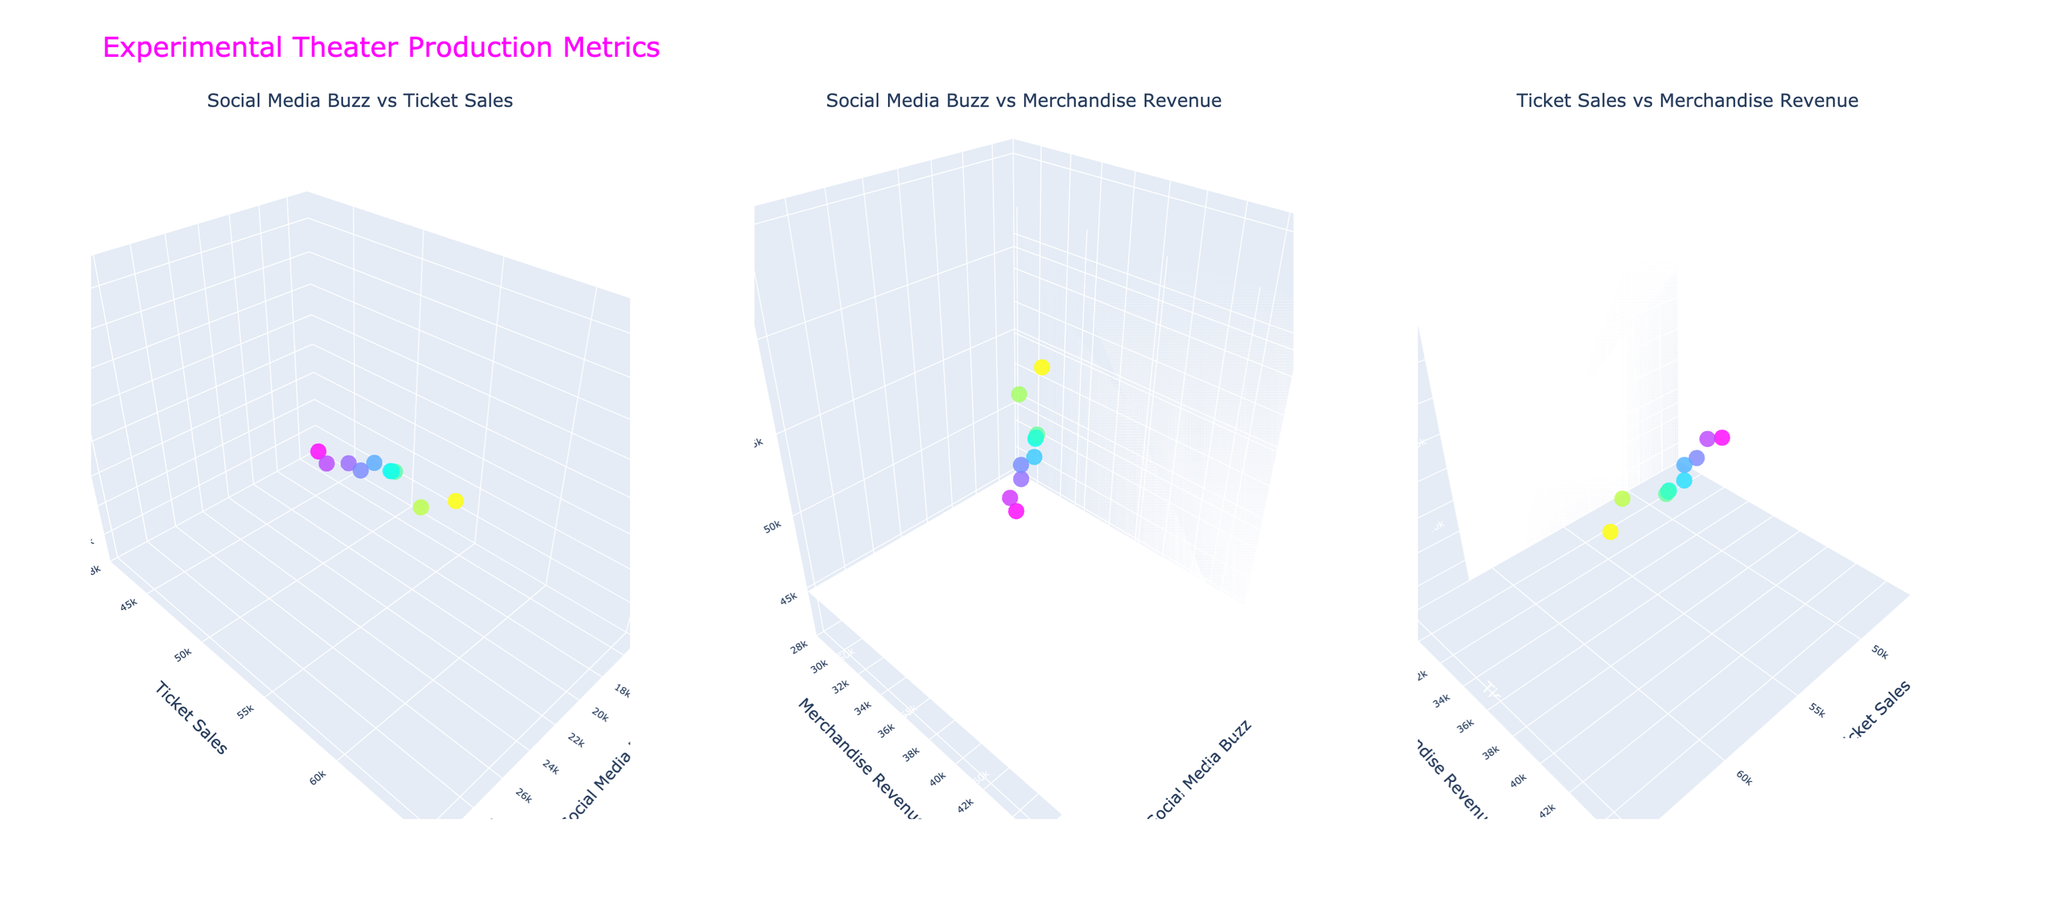Which production has the highest social media buzz? "Cyberpunk Cabaret" appears at the highest level on the x-axis for Social Media Buzz in all three subplots.
Answer: Cyberpunk Cabaret What is the relationship between ticket sales and merchandise revenue for "Quantum Echoes"? "Quantum Echoes" has ticket sales of 55,000 and merchandise revenue of 37,000, as shown on the y-axis and z-axis respectively in the subplots.
Answer: 55,000 ticket sales and 37,000 merchandise revenue Which subplot shows the strongest visual correlation? The first subplot "Social Media Buzz vs Ticket Sales" shows a noticeable trend where as Social Media Buzz increases, Ticket Sales also seem to increase, indicating a positive correlation.
Answer: Social Media Buzz vs Ticket Sales How many productions have a merchandise revenue above 40,000? By examining the z-axis in the subplots, we can see "Cyberpunk Cabaret" and "Glitch in Reality" have merchandise revenues above the 40,000 mark.
Answer: 2 productions Which production has the lowest ticket sales? "Fractal Frequencies" appears to be at the lowest point on the y-axis for Ticket Sales in all relevant subplots.
Answer: Fractal Frequencies Are there any productions that have similar values for all three metrics? "Quantum Echoes" and "Holographic Dreams" both have closely comparable values in all three metrics as they appear close to each other in all three subplots.
Answer: Quantum Echoes and Holographic Dreams What is the range of Social Media Buzz values among all productions? The x-axis of the "Social Media Buzz vs Ticket Sales" or "Social Media Buzz vs Merchandise Revenue" subplots span from 15,000 to 30,000.
Answer: 15,000 to 30,000 Which subplot would help to identify outliers in merchandise revenue visually? The "Social Media Buzz vs Merchandise Revenue" subplot effectively shows outliers in merchandise revenue against Social Media Buzz.
Answer: Social Media Buzz vs Merchandise Revenue 